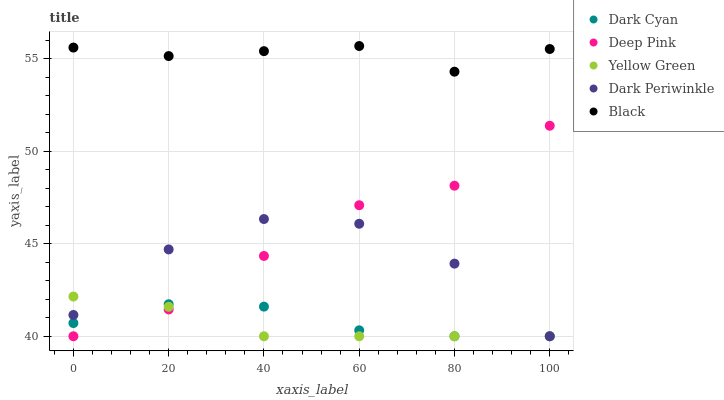Does Yellow Green have the minimum area under the curve?
Answer yes or no. Yes. Does Black have the maximum area under the curve?
Answer yes or no. Yes. Does Deep Pink have the minimum area under the curve?
Answer yes or no. No. Does Deep Pink have the maximum area under the curve?
Answer yes or no. No. Is Yellow Green the smoothest?
Answer yes or no. Yes. Is Dark Periwinkle the roughest?
Answer yes or no. Yes. Is Deep Pink the smoothest?
Answer yes or no. No. Is Deep Pink the roughest?
Answer yes or no. No. Does Dark Cyan have the lowest value?
Answer yes or no. Yes. Does Black have the lowest value?
Answer yes or no. No. Does Black have the highest value?
Answer yes or no. Yes. Does Deep Pink have the highest value?
Answer yes or no. No. Is Dark Cyan less than Black?
Answer yes or no. Yes. Is Black greater than Dark Cyan?
Answer yes or no. Yes. Does Dark Periwinkle intersect Dark Cyan?
Answer yes or no. Yes. Is Dark Periwinkle less than Dark Cyan?
Answer yes or no. No. Is Dark Periwinkle greater than Dark Cyan?
Answer yes or no. No. Does Dark Cyan intersect Black?
Answer yes or no. No. 